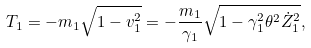Convert formula to latex. <formula><loc_0><loc_0><loc_500><loc_500>T _ { 1 } = - m _ { 1 } \sqrt { 1 - v _ { 1 } ^ { 2 } } = - \frac { m _ { 1 } } { \gamma _ { 1 } } \sqrt { 1 - \gamma _ { 1 } ^ { 2 } \theta ^ { 2 } \dot { Z } _ { 1 } ^ { 2 } } ,</formula> 